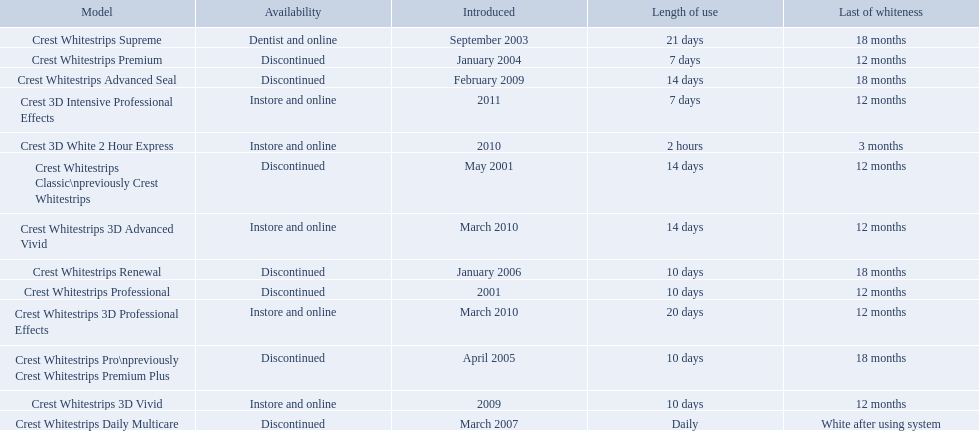What were the models of crest whitestrips? Crest Whitestrips Classic\npreviously Crest Whitestrips, Crest Whitestrips Professional, Crest Whitestrips Supreme, Crest Whitestrips Premium, Crest Whitestrips Pro\npreviously Crest Whitestrips Premium Plus, Crest Whitestrips Renewal, Crest Whitestrips Daily Multicare, Crest Whitestrips Advanced Seal, Crest Whitestrips 3D Vivid, Crest Whitestrips 3D Advanced Vivid, Crest Whitestrips 3D Professional Effects, Crest 3D White 2 Hour Express, Crest 3D Intensive Professional Effects. When were they introduced? May 2001, 2001, September 2003, January 2004, April 2005, January 2006, March 2007, February 2009, 2009, March 2010, March 2010, 2010, 2011. And what is their availability? Discontinued, Discontinued, Dentist and online, Discontinued, Discontinued, Discontinued, Discontinued, Discontinued, Instore and online, Instore and online, Instore and online, Instore and online, Instore and online. Along crest whitestrips 3d vivid, which discontinued model was released in 2009? Crest Whitestrips Advanced Seal. 